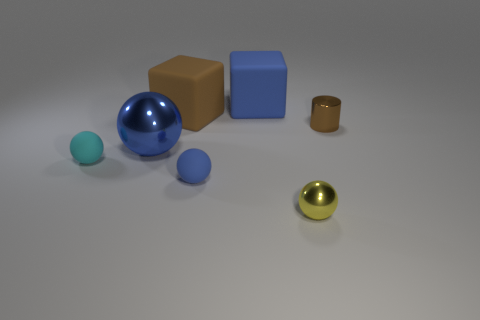Add 1 brown matte blocks. How many objects exist? 8 Subtract all spheres. How many objects are left? 3 Add 4 tiny cylinders. How many tiny cylinders exist? 5 Subtract 1 yellow spheres. How many objects are left? 6 Subtract all large blue matte cylinders. Subtract all large blue metallic things. How many objects are left? 6 Add 5 small brown metallic things. How many small brown metallic things are left? 6 